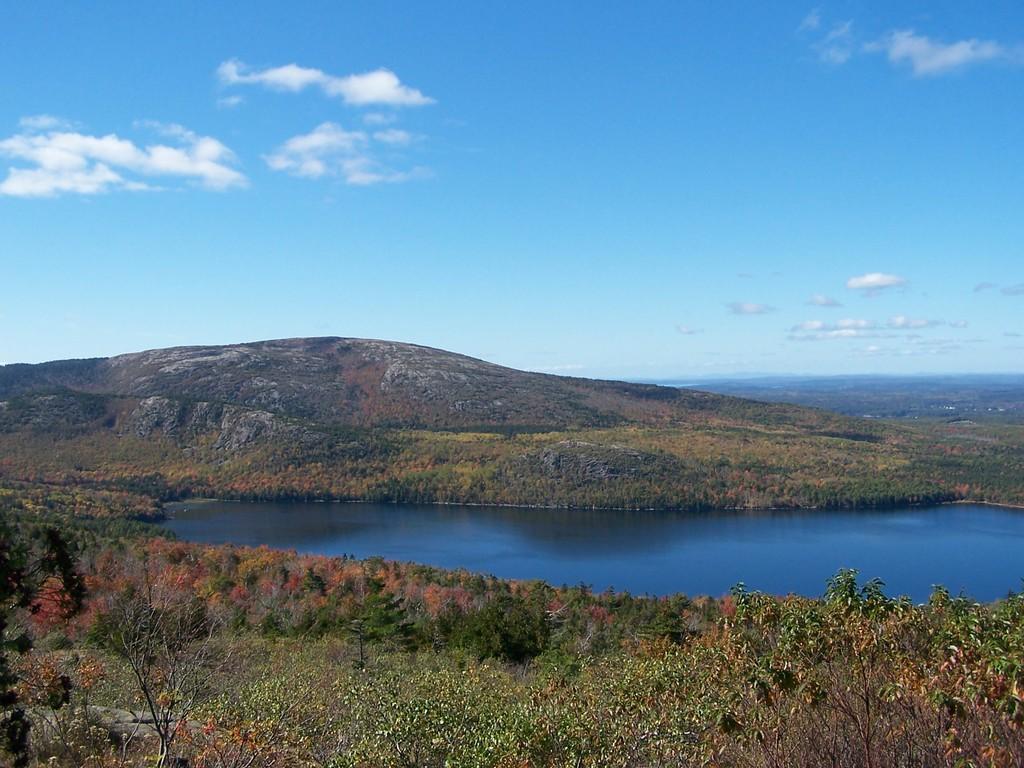Describe this image in one or two sentences. In the image we can see the river, trees, hill and the sky. 